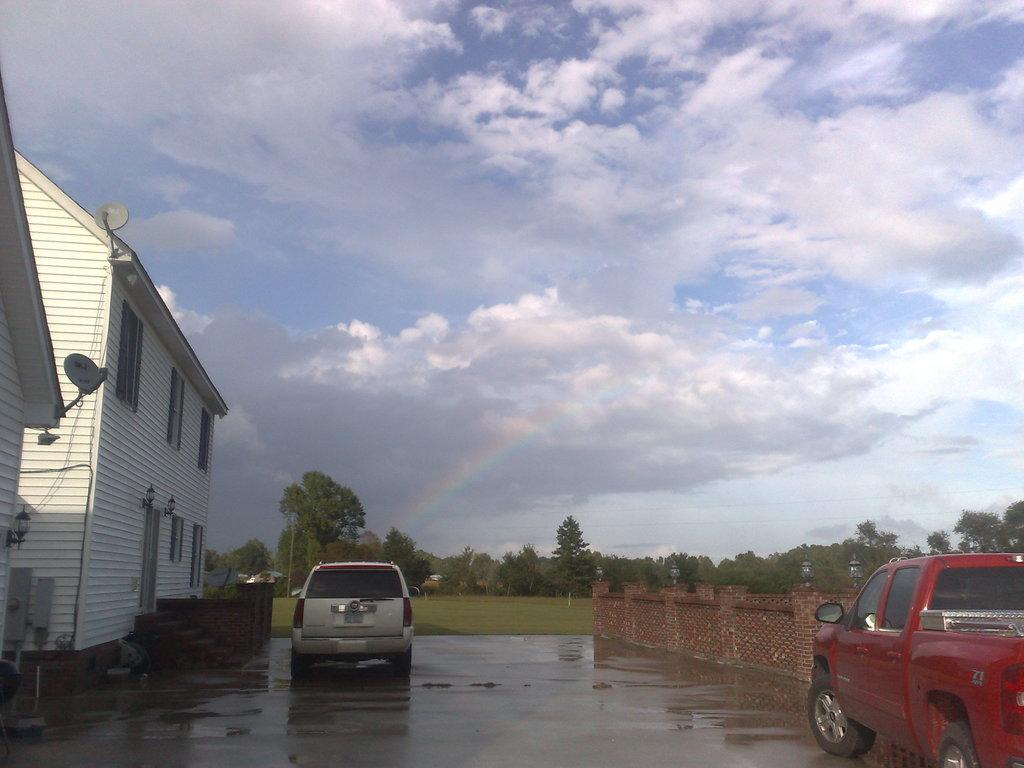What is the main feature of the image? There is a road in the image. What can be seen on the road? Two cars are parked on the road. What type of building is on the right side of the image? There is a white-colored house on the right side of the image. What is visible in the background of the image? The sky is visible in the image, and clouds are present in the sky. How many plantations are visible in the image? There are no plantations present in the image. What type of pot is used for watering the plants in the image? There are no plants or pots visible in the image. 